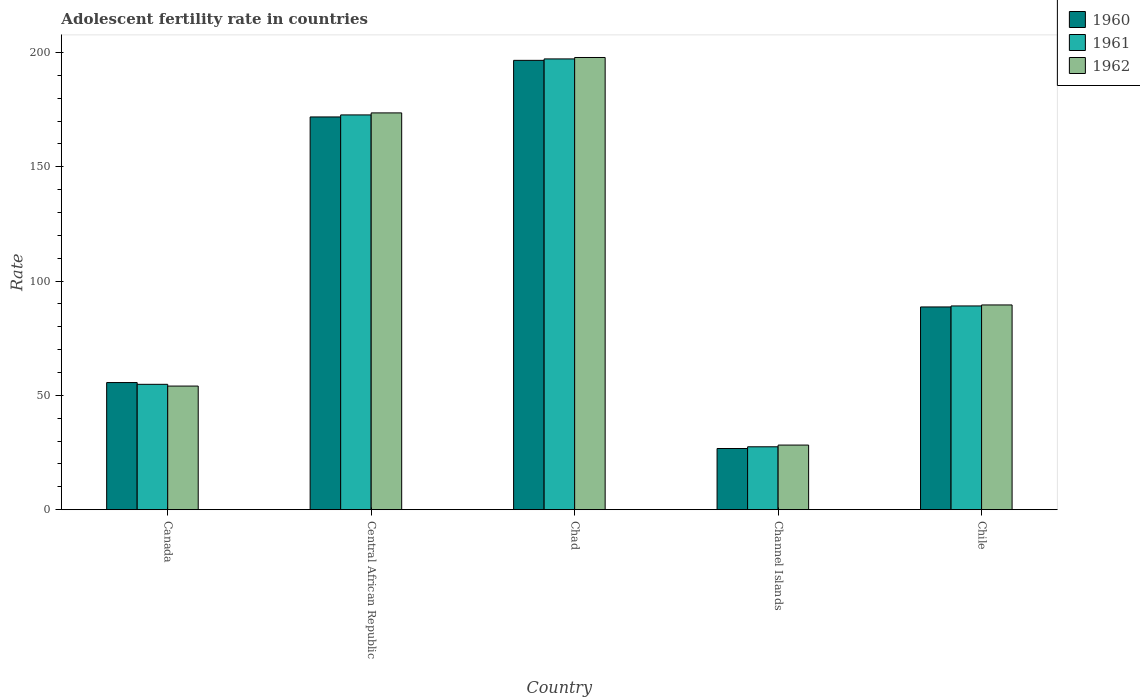How many different coloured bars are there?
Provide a short and direct response. 3. How many groups of bars are there?
Provide a short and direct response. 5. Are the number of bars on each tick of the X-axis equal?
Keep it short and to the point. Yes. How many bars are there on the 2nd tick from the right?
Keep it short and to the point. 3. What is the label of the 4th group of bars from the left?
Offer a terse response. Channel Islands. In how many cases, is the number of bars for a given country not equal to the number of legend labels?
Provide a short and direct response. 0. What is the adolescent fertility rate in 1962 in Chad?
Offer a very short reply. 197.82. Across all countries, what is the maximum adolescent fertility rate in 1962?
Offer a very short reply. 197.82. Across all countries, what is the minimum adolescent fertility rate in 1962?
Make the answer very short. 28.27. In which country was the adolescent fertility rate in 1962 maximum?
Offer a very short reply. Chad. In which country was the adolescent fertility rate in 1961 minimum?
Give a very brief answer. Channel Islands. What is the total adolescent fertility rate in 1961 in the graph?
Provide a short and direct response. 541.38. What is the difference between the adolescent fertility rate in 1962 in Chad and that in Channel Islands?
Make the answer very short. 169.55. What is the difference between the adolescent fertility rate in 1960 in Channel Islands and the adolescent fertility rate in 1961 in Central African Republic?
Offer a terse response. -145.93. What is the average adolescent fertility rate in 1960 per country?
Keep it short and to the point. 107.89. What is the difference between the adolescent fertility rate of/in 1960 and adolescent fertility rate of/in 1962 in Channel Islands?
Offer a terse response. -1.5. What is the ratio of the adolescent fertility rate in 1960 in Central African Republic to that in Chad?
Give a very brief answer. 0.87. Is the adolescent fertility rate in 1960 in Chad less than that in Chile?
Ensure brevity in your answer.  No. Is the difference between the adolescent fertility rate in 1960 in Central African Republic and Channel Islands greater than the difference between the adolescent fertility rate in 1962 in Central African Republic and Channel Islands?
Offer a terse response. No. What is the difference between the highest and the second highest adolescent fertility rate in 1961?
Your answer should be compact. -83.57. What is the difference between the highest and the lowest adolescent fertility rate in 1962?
Keep it short and to the point. 169.55. In how many countries, is the adolescent fertility rate in 1960 greater than the average adolescent fertility rate in 1960 taken over all countries?
Your response must be concise. 2. What does the 3rd bar from the left in Chile represents?
Make the answer very short. 1962. What does the 3rd bar from the right in Central African Republic represents?
Ensure brevity in your answer.  1960. Is it the case that in every country, the sum of the adolescent fertility rate in 1962 and adolescent fertility rate in 1961 is greater than the adolescent fertility rate in 1960?
Make the answer very short. Yes. Are all the bars in the graph horizontal?
Offer a very short reply. No. How many countries are there in the graph?
Make the answer very short. 5. What is the difference between two consecutive major ticks on the Y-axis?
Your answer should be very brief. 50. Does the graph contain grids?
Offer a terse response. No. How are the legend labels stacked?
Your answer should be compact. Vertical. What is the title of the graph?
Provide a short and direct response. Adolescent fertility rate in countries. What is the label or title of the Y-axis?
Provide a succinct answer. Rate. What is the Rate of 1960 in Canada?
Make the answer very short. 55.62. What is the Rate of 1961 in Canada?
Offer a very short reply. 54.85. What is the Rate in 1962 in Canada?
Offer a very short reply. 54.08. What is the Rate of 1960 in Central African Republic?
Your response must be concise. 171.81. What is the Rate in 1961 in Central African Republic?
Make the answer very short. 172.7. What is the Rate of 1962 in Central African Republic?
Your answer should be very brief. 173.58. What is the Rate in 1960 in Chad?
Provide a succinct answer. 196.56. What is the Rate in 1961 in Chad?
Your response must be concise. 197.19. What is the Rate in 1962 in Chad?
Offer a terse response. 197.82. What is the Rate of 1960 in Channel Islands?
Provide a succinct answer. 26.77. What is the Rate of 1961 in Channel Islands?
Your response must be concise. 27.52. What is the Rate of 1962 in Channel Islands?
Provide a succinct answer. 28.27. What is the Rate of 1960 in Chile?
Your answer should be very brief. 88.69. What is the Rate in 1961 in Chile?
Your response must be concise. 89.13. What is the Rate of 1962 in Chile?
Your answer should be very brief. 89.57. Across all countries, what is the maximum Rate of 1960?
Keep it short and to the point. 196.56. Across all countries, what is the maximum Rate in 1961?
Your answer should be very brief. 197.19. Across all countries, what is the maximum Rate in 1962?
Your answer should be very brief. 197.82. Across all countries, what is the minimum Rate of 1960?
Offer a terse response. 26.77. Across all countries, what is the minimum Rate in 1961?
Provide a succinct answer. 27.52. Across all countries, what is the minimum Rate in 1962?
Your answer should be very brief. 28.27. What is the total Rate in 1960 in the graph?
Your answer should be very brief. 539.45. What is the total Rate in 1961 in the graph?
Your answer should be very brief. 541.38. What is the total Rate of 1962 in the graph?
Give a very brief answer. 543.32. What is the difference between the Rate in 1960 in Canada and that in Central African Republic?
Ensure brevity in your answer.  -116.2. What is the difference between the Rate of 1961 in Canada and that in Central African Republic?
Your answer should be compact. -117.85. What is the difference between the Rate of 1962 in Canada and that in Central African Republic?
Provide a short and direct response. -119.5. What is the difference between the Rate of 1960 in Canada and that in Chad?
Provide a succinct answer. -140.95. What is the difference between the Rate of 1961 in Canada and that in Chad?
Provide a short and direct response. -142.34. What is the difference between the Rate of 1962 in Canada and that in Chad?
Make the answer very short. -143.74. What is the difference between the Rate of 1960 in Canada and that in Channel Islands?
Provide a succinct answer. 28.85. What is the difference between the Rate in 1961 in Canada and that in Channel Islands?
Offer a very short reply. 27.33. What is the difference between the Rate in 1962 in Canada and that in Channel Islands?
Offer a very short reply. 25.81. What is the difference between the Rate of 1960 in Canada and that in Chile?
Your answer should be compact. -33.08. What is the difference between the Rate of 1961 in Canada and that in Chile?
Offer a terse response. -34.28. What is the difference between the Rate in 1962 in Canada and that in Chile?
Provide a succinct answer. -35.49. What is the difference between the Rate in 1960 in Central African Republic and that in Chad?
Give a very brief answer. -24.75. What is the difference between the Rate in 1961 in Central African Republic and that in Chad?
Give a very brief answer. -24.5. What is the difference between the Rate in 1962 in Central African Republic and that in Chad?
Offer a terse response. -24.24. What is the difference between the Rate in 1960 in Central African Republic and that in Channel Islands?
Keep it short and to the point. 145.04. What is the difference between the Rate of 1961 in Central African Republic and that in Channel Islands?
Your answer should be very brief. 145.18. What is the difference between the Rate in 1962 in Central African Republic and that in Channel Islands?
Your answer should be very brief. 145.31. What is the difference between the Rate of 1960 in Central African Republic and that in Chile?
Provide a short and direct response. 83.12. What is the difference between the Rate in 1961 in Central African Republic and that in Chile?
Your answer should be compact. 83.57. What is the difference between the Rate of 1962 in Central African Republic and that in Chile?
Give a very brief answer. 84.01. What is the difference between the Rate of 1960 in Chad and that in Channel Islands?
Your answer should be very brief. 169.8. What is the difference between the Rate of 1961 in Chad and that in Channel Islands?
Provide a short and direct response. 169.67. What is the difference between the Rate in 1962 in Chad and that in Channel Islands?
Offer a terse response. 169.55. What is the difference between the Rate of 1960 in Chad and that in Chile?
Give a very brief answer. 107.87. What is the difference between the Rate in 1961 in Chad and that in Chile?
Make the answer very short. 108.06. What is the difference between the Rate of 1962 in Chad and that in Chile?
Keep it short and to the point. 108.25. What is the difference between the Rate in 1960 in Channel Islands and that in Chile?
Give a very brief answer. -61.92. What is the difference between the Rate in 1961 in Channel Islands and that in Chile?
Your answer should be very brief. -61.61. What is the difference between the Rate in 1962 in Channel Islands and that in Chile?
Keep it short and to the point. -61.3. What is the difference between the Rate of 1960 in Canada and the Rate of 1961 in Central African Republic?
Provide a succinct answer. -117.08. What is the difference between the Rate in 1960 in Canada and the Rate in 1962 in Central African Republic?
Ensure brevity in your answer.  -117.96. What is the difference between the Rate in 1961 in Canada and the Rate in 1962 in Central African Republic?
Your answer should be compact. -118.73. What is the difference between the Rate in 1960 in Canada and the Rate in 1961 in Chad?
Provide a succinct answer. -141.58. What is the difference between the Rate of 1960 in Canada and the Rate of 1962 in Chad?
Offer a very short reply. -142.2. What is the difference between the Rate in 1961 in Canada and the Rate in 1962 in Chad?
Your answer should be very brief. -142.97. What is the difference between the Rate of 1960 in Canada and the Rate of 1961 in Channel Islands?
Keep it short and to the point. 28.1. What is the difference between the Rate in 1960 in Canada and the Rate in 1962 in Channel Islands?
Offer a very short reply. 27.35. What is the difference between the Rate of 1961 in Canada and the Rate of 1962 in Channel Islands?
Make the answer very short. 26.58. What is the difference between the Rate in 1960 in Canada and the Rate in 1961 in Chile?
Ensure brevity in your answer.  -33.51. What is the difference between the Rate of 1960 in Canada and the Rate of 1962 in Chile?
Your answer should be very brief. -33.95. What is the difference between the Rate of 1961 in Canada and the Rate of 1962 in Chile?
Offer a very short reply. -34.72. What is the difference between the Rate in 1960 in Central African Republic and the Rate in 1961 in Chad?
Ensure brevity in your answer.  -25.38. What is the difference between the Rate in 1960 in Central African Republic and the Rate in 1962 in Chad?
Make the answer very short. -26.01. What is the difference between the Rate in 1961 in Central African Republic and the Rate in 1962 in Chad?
Provide a short and direct response. -25.12. What is the difference between the Rate of 1960 in Central African Republic and the Rate of 1961 in Channel Islands?
Make the answer very short. 144.29. What is the difference between the Rate in 1960 in Central African Republic and the Rate in 1962 in Channel Islands?
Provide a succinct answer. 143.54. What is the difference between the Rate in 1961 in Central African Republic and the Rate in 1962 in Channel Islands?
Offer a very short reply. 144.43. What is the difference between the Rate of 1960 in Central African Republic and the Rate of 1961 in Chile?
Provide a succinct answer. 82.68. What is the difference between the Rate in 1960 in Central African Republic and the Rate in 1962 in Chile?
Provide a succinct answer. 82.25. What is the difference between the Rate in 1961 in Central African Republic and the Rate in 1962 in Chile?
Ensure brevity in your answer.  83.13. What is the difference between the Rate in 1960 in Chad and the Rate in 1961 in Channel Islands?
Offer a very short reply. 169.05. What is the difference between the Rate of 1960 in Chad and the Rate of 1962 in Channel Islands?
Make the answer very short. 168.29. What is the difference between the Rate of 1961 in Chad and the Rate of 1962 in Channel Islands?
Give a very brief answer. 168.92. What is the difference between the Rate of 1960 in Chad and the Rate of 1961 in Chile?
Your answer should be very brief. 107.43. What is the difference between the Rate in 1960 in Chad and the Rate in 1962 in Chile?
Give a very brief answer. 107. What is the difference between the Rate in 1961 in Chad and the Rate in 1962 in Chile?
Your response must be concise. 107.62. What is the difference between the Rate in 1960 in Channel Islands and the Rate in 1961 in Chile?
Your response must be concise. -62.36. What is the difference between the Rate in 1960 in Channel Islands and the Rate in 1962 in Chile?
Give a very brief answer. -62.8. What is the difference between the Rate in 1961 in Channel Islands and the Rate in 1962 in Chile?
Keep it short and to the point. -62.05. What is the average Rate of 1960 per country?
Keep it short and to the point. 107.89. What is the average Rate in 1961 per country?
Your answer should be compact. 108.28. What is the average Rate of 1962 per country?
Ensure brevity in your answer.  108.66. What is the difference between the Rate of 1960 and Rate of 1961 in Canada?
Ensure brevity in your answer.  0.77. What is the difference between the Rate of 1960 and Rate of 1962 in Canada?
Offer a very short reply. 1.54. What is the difference between the Rate of 1961 and Rate of 1962 in Canada?
Your response must be concise. 0.77. What is the difference between the Rate of 1960 and Rate of 1961 in Central African Republic?
Give a very brief answer. -0.88. What is the difference between the Rate in 1960 and Rate in 1962 in Central African Republic?
Give a very brief answer. -1.77. What is the difference between the Rate in 1961 and Rate in 1962 in Central African Republic?
Offer a very short reply. -0.88. What is the difference between the Rate in 1960 and Rate in 1961 in Chad?
Ensure brevity in your answer.  -0.63. What is the difference between the Rate of 1960 and Rate of 1962 in Chad?
Offer a very short reply. -1.26. What is the difference between the Rate in 1961 and Rate in 1962 in Chad?
Ensure brevity in your answer.  -0.63. What is the difference between the Rate of 1960 and Rate of 1961 in Channel Islands?
Keep it short and to the point. -0.75. What is the difference between the Rate of 1960 and Rate of 1962 in Channel Islands?
Your answer should be compact. -1.5. What is the difference between the Rate in 1961 and Rate in 1962 in Channel Islands?
Give a very brief answer. -0.75. What is the difference between the Rate of 1960 and Rate of 1961 in Chile?
Ensure brevity in your answer.  -0.44. What is the difference between the Rate in 1960 and Rate in 1962 in Chile?
Make the answer very short. -0.88. What is the difference between the Rate of 1961 and Rate of 1962 in Chile?
Your response must be concise. -0.44. What is the ratio of the Rate in 1960 in Canada to that in Central African Republic?
Your answer should be very brief. 0.32. What is the ratio of the Rate in 1961 in Canada to that in Central African Republic?
Give a very brief answer. 0.32. What is the ratio of the Rate in 1962 in Canada to that in Central African Republic?
Your answer should be very brief. 0.31. What is the ratio of the Rate of 1960 in Canada to that in Chad?
Keep it short and to the point. 0.28. What is the ratio of the Rate in 1961 in Canada to that in Chad?
Keep it short and to the point. 0.28. What is the ratio of the Rate of 1962 in Canada to that in Chad?
Offer a terse response. 0.27. What is the ratio of the Rate in 1960 in Canada to that in Channel Islands?
Your answer should be very brief. 2.08. What is the ratio of the Rate of 1961 in Canada to that in Channel Islands?
Keep it short and to the point. 1.99. What is the ratio of the Rate of 1962 in Canada to that in Channel Islands?
Offer a terse response. 1.91. What is the ratio of the Rate of 1960 in Canada to that in Chile?
Ensure brevity in your answer.  0.63. What is the ratio of the Rate of 1961 in Canada to that in Chile?
Offer a terse response. 0.62. What is the ratio of the Rate in 1962 in Canada to that in Chile?
Provide a short and direct response. 0.6. What is the ratio of the Rate in 1960 in Central African Republic to that in Chad?
Offer a terse response. 0.87. What is the ratio of the Rate in 1961 in Central African Republic to that in Chad?
Your answer should be very brief. 0.88. What is the ratio of the Rate of 1962 in Central African Republic to that in Chad?
Make the answer very short. 0.88. What is the ratio of the Rate of 1960 in Central African Republic to that in Channel Islands?
Keep it short and to the point. 6.42. What is the ratio of the Rate of 1961 in Central African Republic to that in Channel Islands?
Your response must be concise. 6.28. What is the ratio of the Rate in 1962 in Central African Republic to that in Channel Islands?
Offer a terse response. 6.14. What is the ratio of the Rate in 1960 in Central African Republic to that in Chile?
Give a very brief answer. 1.94. What is the ratio of the Rate of 1961 in Central African Republic to that in Chile?
Your answer should be very brief. 1.94. What is the ratio of the Rate of 1962 in Central African Republic to that in Chile?
Provide a short and direct response. 1.94. What is the ratio of the Rate of 1960 in Chad to that in Channel Islands?
Offer a terse response. 7.34. What is the ratio of the Rate of 1961 in Chad to that in Channel Islands?
Your response must be concise. 7.17. What is the ratio of the Rate of 1962 in Chad to that in Channel Islands?
Ensure brevity in your answer.  7. What is the ratio of the Rate in 1960 in Chad to that in Chile?
Offer a very short reply. 2.22. What is the ratio of the Rate in 1961 in Chad to that in Chile?
Provide a short and direct response. 2.21. What is the ratio of the Rate in 1962 in Chad to that in Chile?
Keep it short and to the point. 2.21. What is the ratio of the Rate in 1960 in Channel Islands to that in Chile?
Provide a succinct answer. 0.3. What is the ratio of the Rate of 1961 in Channel Islands to that in Chile?
Offer a very short reply. 0.31. What is the ratio of the Rate in 1962 in Channel Islands to that in Chile?
Ensure brevity in your answer.  0.32. What is the difference between the highest and the second highest Rate in 1960?
Offer a terse response. 24.75. What is the difference between the highest and the second highest Rate in 1961?
Your answer should be very brief. 24.5. What is the difference between the highest and the second highest Rate of 1962?
Keep it short and to the point. 24.24. What is the difference between the highest and the lowest Rate in 1960?
Offer a very short reply. 169.8. What is the difference between the highest and the lowest Rate of 1961?
Provide a succinct answer. 169.67. What is the difference between the highest and the lowest Rate in 1962?
Your answer should be compact. 169.55. 